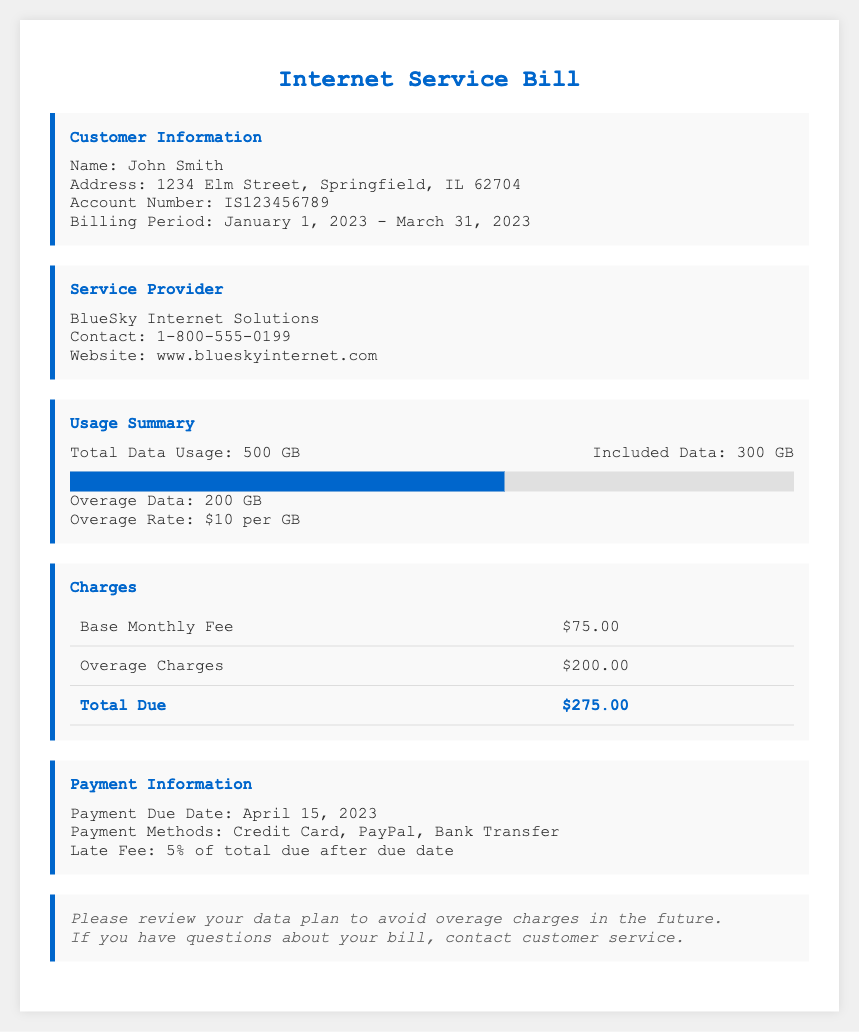What is the total data usage? The total data usage is specified in the usage summary section of the document, which is 500 GB.
Answer: 500 GB What is the included data? The included data is mentioned in the usage summary, which states that the included data is 300 GB.
Answer: 300 GB What is the overage data? The overage data shows how much data was exceeded, which is detailed as 200 GB in the bill.
Answer: 200 GB What is the overage rate per GB? The overage rate is indicated in the usage summary section, which states it is $10 per GB.
Answer: $10 per GB What is the base monthly fee? The base monthly fee is listed in the charges section of the document as $75.00.
Answer: $75.00 What is the total due amount? The total due amount is calculated in the charges section based on the base fee and overage charges, which sums up to $275.00.
Answer: $275.00 When is the payment due date? The payment due date is provided in the payment information section, which is April 15, 2023.
Answer: April 15, 2023 What methods of payment are available? The document states the available payment methods in the payment information section, which are Credit Card, PayPal, and Bank Transfer.
Answer: Credit Card, PayPal, Bank Transfer What should you review to avoid overage charges in the future? The notes section advises reviewing the data plan to avoid overage charges in the future.
Answer: Your data plan 